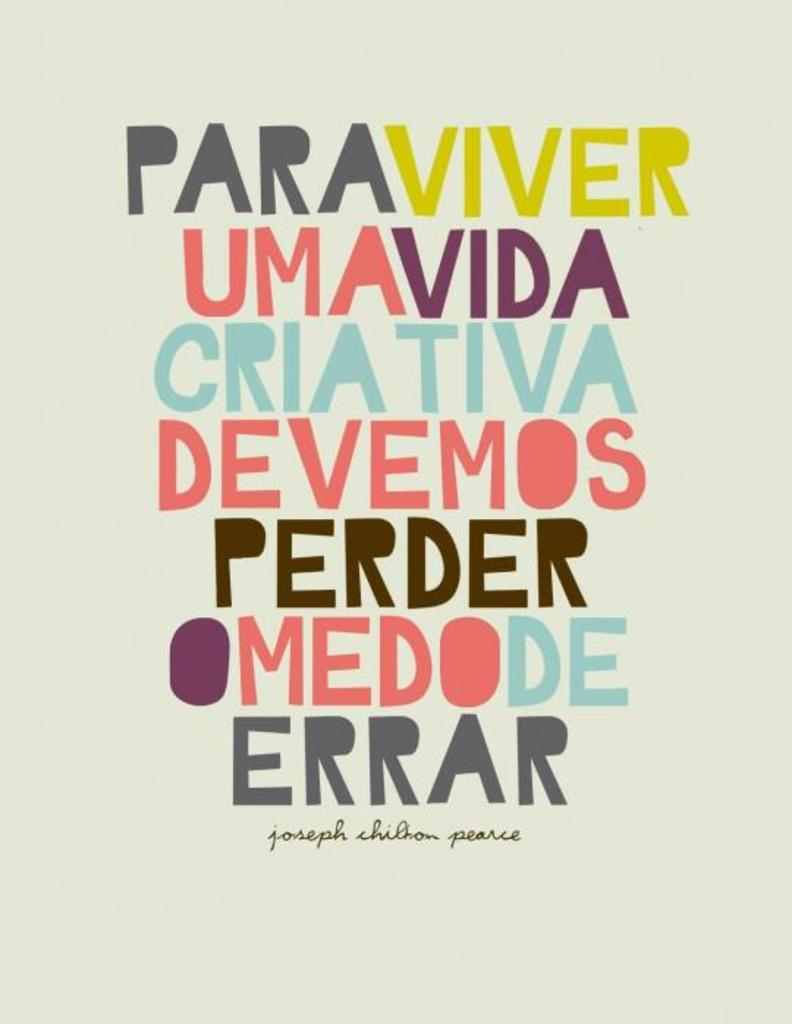What is present in the image that has a design or message? There is a poster in the image. What can be found on the poster in the image? There is text printed on the poster. What type of shoe is depicted in the poster in the image? There is no shoe depicted in the poster or the image. What form of regret is expressed in the poster in the image? There is no expression of regret in the poster or the image, as the facts provided only mention the presence of a poster with text. 